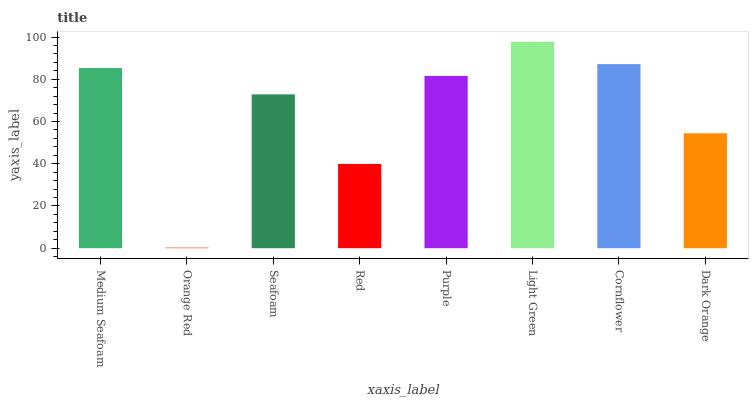Is Orange Red the minimum?
Answer yes or no. Yes. Is Light Green the maximum?
Answer yes or no. Yes. Is Seafoam the minimum?
Answer yes or no. No. Is Seafoam the maximum?
Answer yes or no. No. Is Seafoam greater than Orange Red?
Answer yes or no. Yes. Is Orange Red less than Seafoam?
Answer yes or no. Yes. Is Orange Red greater than Seafoam?
Answer yes or no. No. Is Seafoam less than Orange Red?
Answer yes or no. No. Is Purple the high median?
Answer yes or no. Yes. Is Seafoam the low median?
Answer yes or no. Yes. Is Cornflower the high median?
Answer yes or no. No. Is Medium Seafoam the low median?
Answer yes or no. No. 